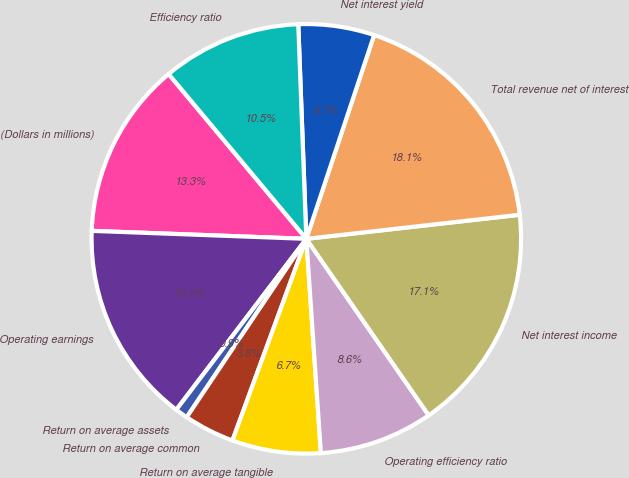Convert chart to OTSL. <chart><loc_0><loc_0><loc_500><loc_500><pie_chart><fcel>(Dollars in millions)<fcel>Operating earnings<fcel>Return on average assets<fcel>Return on average common<fcel>Return on average tangible<fcel>Operating efficiency ratio<fcel>Net interest income<fcel>Total revenue net of interest<fcel>Net interest yield<fcel>Efficiency ratio<nl><fcel>13.33%<fcel>15.24%<fcel>0.95%<fcel>3.81%<fcel>6.67%<fcel>8.57%<fcel>17.14%<fcel>18.1%<fcel>5.71%<fcel>10.48%<nl></chart> 